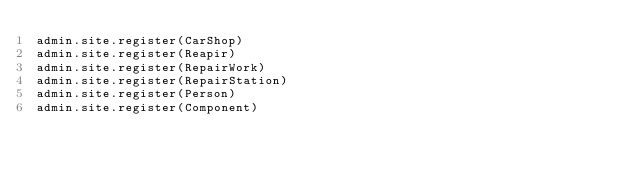<code> <loc_0><loc_0><loc_500><loc_500><_Python_>admin.site.register(CarShop)
admin.site.register(Reapir)
admin.site.register(RepairWork)
admin.site.register(RepairStation)
admin.site.register(Person)
admin.site.register(Component)
</code> 